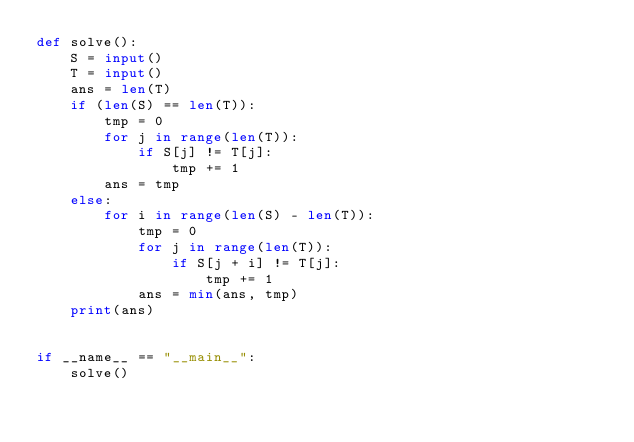Convert code to text. <code><loc_0><loc_0><loc_500><loc_500><_Python_>def solve():
    S = input()
    T = input()
    ans = len(T)
    if (len(S) == len(T)):
        tmp = 0
        for j in range(len(T)):
            if S[j] != T[j]:
                tmp += 1
        ans = tmp
    else:
        for i in range(len(S) - len(T)):
            tmp = 0
            for j in range(len(T)):
                if S[j + i] != T[j]:
                    tmp += 1
            ans = min(ans, tmp)
    print(ans)
        

if __name__ == "__main__":
    solve()</code> 